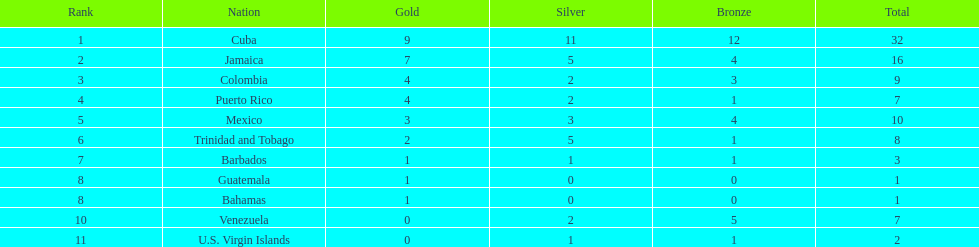Which team obtained four golds and a bronze in their medal tally? Puerto Rico. Help me parse the entirety of this table. {'header': ['Rank', 'Nation', 'Gold', 'Silver', 'Bronze', 'Total'], 'rows': [['1', 'Cuba', '9', '11', '12', '32'], ['2', 'Jamaica', '7', '5', '4', '16'], ['3', 'Colombia', '4', '2', '3', '9'], ['4', 'Puerto Rico', '4', '2', '1', '7'], ['5', 'Mexico', '3', '3', '4', '10'], ['6', 'Trinidad and Tobago', '2', '5', '1', '8'], ['7', 'Barbados', '1', '1', '1', '3'], ['8', 'Guatemala', '1', '0', '0', '1'], ['8', 'Bahamas', '1', '0', '0', '1'], ['10', 'Venezuela', '0', '2', '5', '7'], ['11', 'U.S. Virgin Islands', '0', '1', '1', '2']]} 